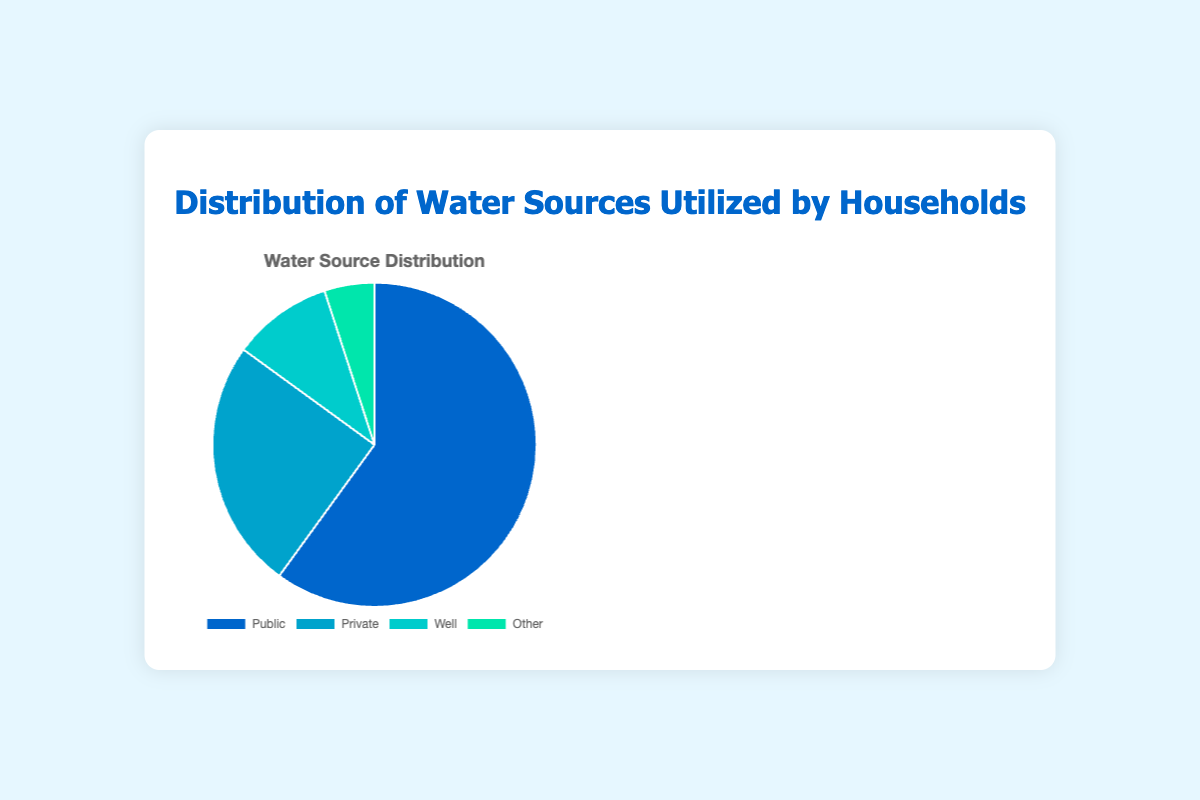what percentage of households utilize public water sources? The pie chart shows the distribution of water sources utilized by households. The segment labeled 'Public' represents 60% of the total distribution.
Answer: 60% Which water source is used the least by households? By visually inspecting the pie chart, the smallest segment is labeled 'Other,' which represents 5% of the total distribution.
Answer: Other What is the combined percentage of households using well and other water sources? The pie chart shows that the 'Well' segment represents 10% and the 'Other' segment represents 5%. Adding these percentages together gives 10% + 5% = 15%.
Answer: 15% How much greater is the percentage of households using public water sources compared to those using private water sources? The pie chart shows that public water sources are utilized by 60% of households while private water sources are utilized by 25%. The difference is 60% - 25% = 35%.
Answer: 35% Which water source represents a quarter of the households' utilization? By inspecting the pie chart, the segment labeled 'Private' represents 25% of the total distribution, which is a quarter.
Answer: Private Is the percentage of households using private water sources greater than the combined percentage of those using well and other water sources? The pie chart shows that private water sources make up 25%, while the combined total for well (10%) and other (5%) is 15%. Since 25% > 15%, the percentage of households using private water sources is indeed greater.
Answer: Yes Which water source appears in blue color on the chart? By examining the description of the chart's visual attributes, the 'Public' segment is associated with the color blue.
Answer: Public How does the utilization of public water sources compare to the combined utilization of all other sources? The pie chart shows that public water sources account for 60% of the total, while the combined percentage for private (25%), well (10%), and other (5%) sources is 40%. Public water source utilization (60%) is greater than the combined utilization of all other sources (40%).
Answer: Greater 